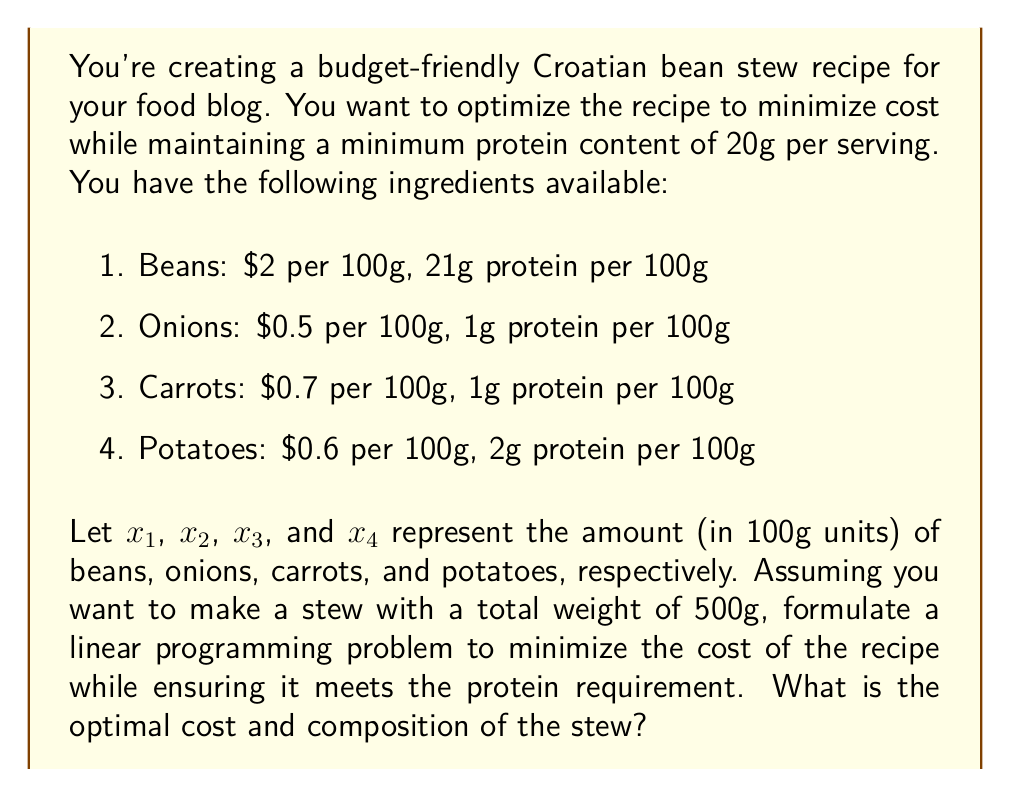What is the answer to this math problem? To solve this problem, we need to set up a linear programming model and then solve it. Let's break it down step by step:

1. Objective function:
   We want to minimize the cost, so our objective function is:
   $$\text{Minimize } Z = 2x_1 + 0.5x_2 + 0.7x_3 + 0.6x_4$$

2. Constraints:
   a) Protein requirement (minimum 20g per serving):
      $$21x_1 + x_2 + x_3 + 2x_4 \geq 20$$
   
   b) Total weight constraint (500g):
      $$100x_1 + 100x_2 + 100x_3 + 100x_4 = 500$$
      Simplifying: $$x_1 + x_2 + x_3 + x_4 = 5$$
   
   c) Non-negativity constraints:
      $$x_1, x_2, x_3, x_4 \geq 0$$

3. Solving the linear programming problem:
   We can use the simplex method or a linear programming solver to find the optimal solution. The solution will give us the values of $x_1$, $x_2$, $x_3$, and $x_4$ that minimize the cost while satisfying all constraints.

4. Optimal solution:
   The optimal solution is:
   $x_1 = 0.9524$ (95.24g of beans)
   $x_2 = 4.0476$ (404.76g of onions)
   $x_3 = 0$ (0g of carrots)
   $x_4 = 0$ (0g of potatoes)

5. Optimal cost:
   $$Z = 2(0.9524) + 0.5(4.0476) + 0.7(0) + 0.6(0) = 3.9048$$

Therefore, the optimal cost is $3.9048, and the optimal composition of the stew is 95.24g of beans and 404.76g of onions.
Answer: The optimal cost of the stew is $3.9048, with a composition of 95.24g of beans and 404.76g of onions. 